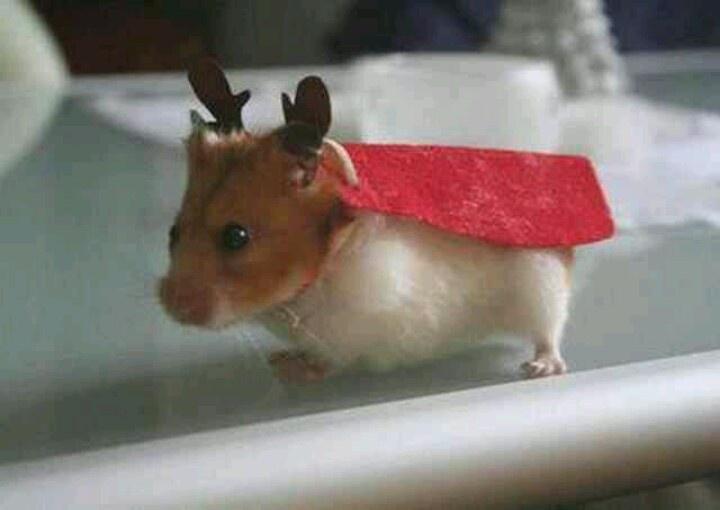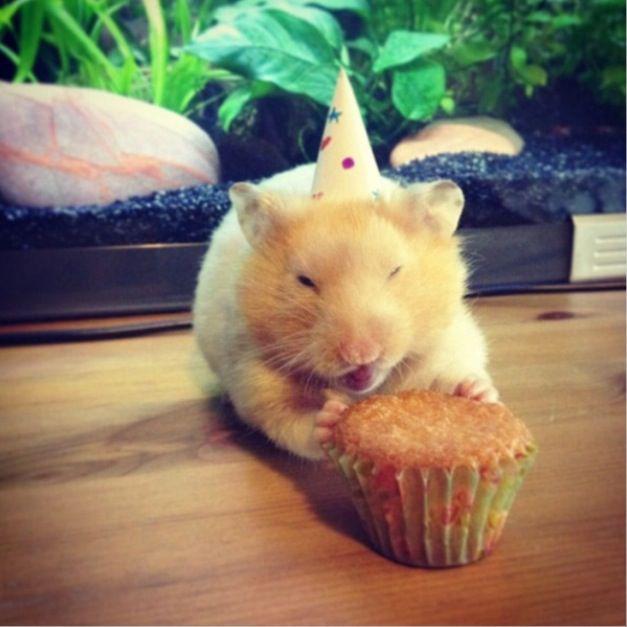The first image is the image on the left, the second image is the image on the right. For the images displayed, is the sentence "Little animals are shown with tiny musical instruments and an audition sign." factually correct? Answer yes or no. No. 